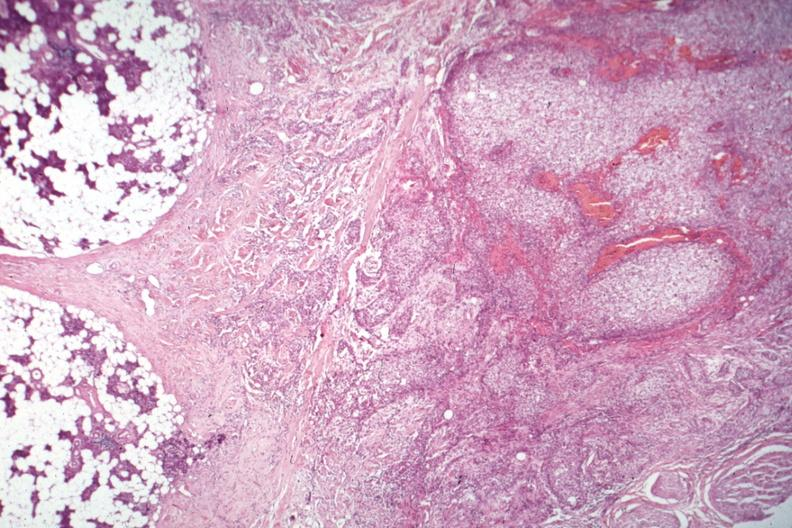how many side does this image show nice photo of parotid on with tumor capsule and obvious invasive tumor?
Answer the question using a single word or phrase. One 